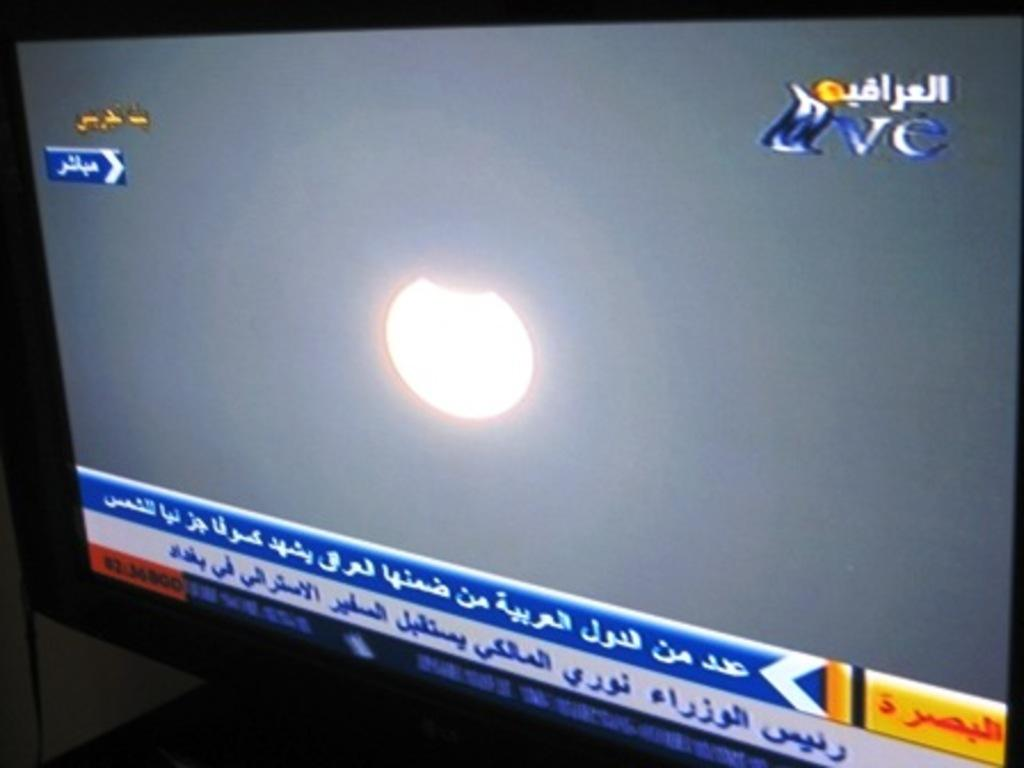What electronic device can be seen in the image? There is a TV in the image. Where is the TV placed? The TV is on a platform. What information is displayed on the TV screen? There are headlines visible on the TV screen. What celestial body can be seen in the sky? The moon is visible in the sky. What type of peace treaty is being discussed in the image? There is no discussion or peace treaty present in the image; it features a TV on a platform with headlines on the screen and the moon visible in the sky. 